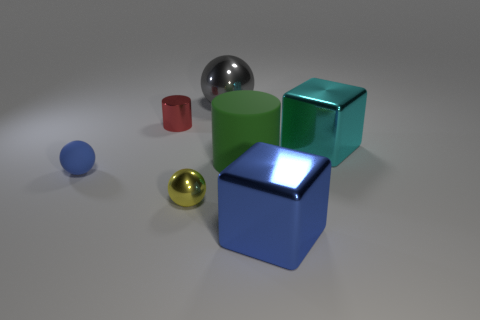What is the size of the cube that is the same color as the tiny rubber thing?
Your response must be concise. Large. Is there a metallic block that has the same color as the small rubber thing?
Your answer should be compact. Yes. There is a rubber ball; is its color the same as the big cube in front of the yellow metal thing?
Your answer should be compact. Yes. Are there fewer large green cylinders that are behind the big green cylinder than purple metallic spheres?
Your answer should be very brief. No. What is the material of the big object that is in front of the small rubber thing?
Ensure brevity in your answer.  Metal. What number of other things are the same size as the gray metal sphere?
Offer a very short reply. 3. Are there fewer large yellow rubber cylinders than blocks?
Offer a terse response. Yes. There is a large blue shiny thing; what shape is it?
Ensure brevity in your answer.  Cube. Do the block in front of the cyan block and the rubber sphere have the same color?
Offer a terse response. Yes. The metal object that is both in front of the big rubber object and to the left of the large gray sphere has what shape?
Offer a very short reply. Sphere. 